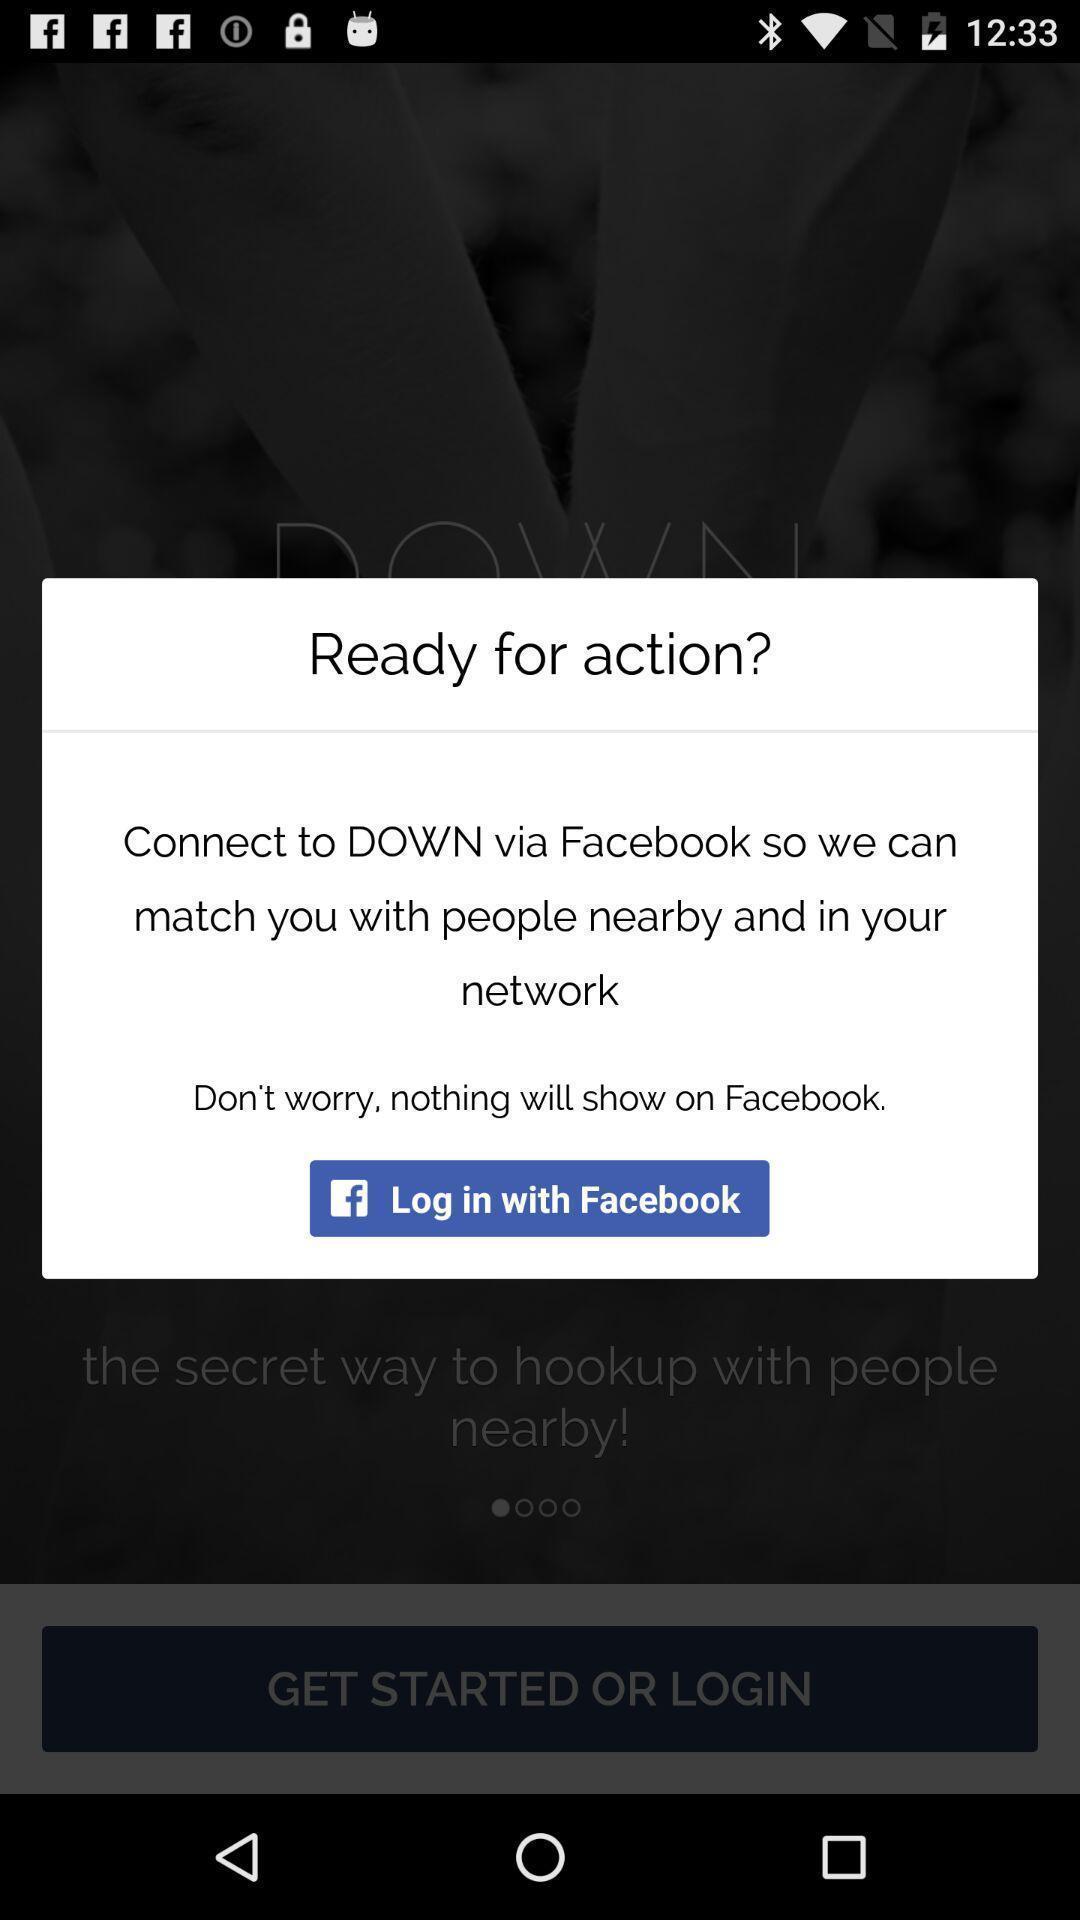Provide a description of this screenshot. Pop-up displaying to login with a social app. 